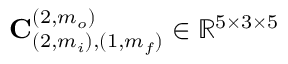Convert formula to latex. <formula><loc_0><loc_0><loc_500><loc_500>C _ { ( 2 , m _ { i } ) , ( 1 , m _ { f } ) } ^ { ( 2 , m _ { o } ) } \in \mathbb { R } ^ { 5 \times 3 \times 5 }</formula> 